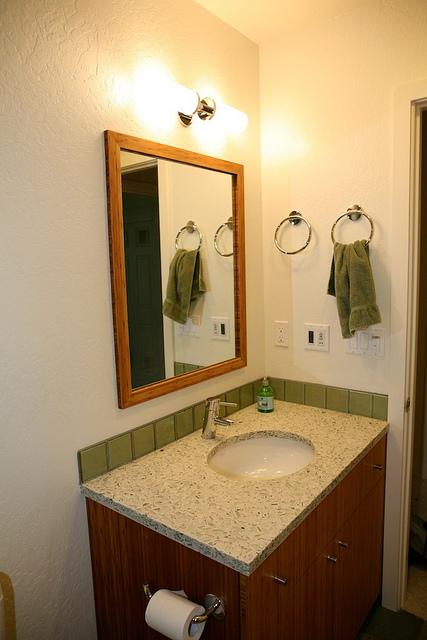How many handles are on the left side of the bathroom cabinet?
Write a very short answer. 1. Where are the lights?
Short answer required. Bathroom. How many light fixtures are in this picture?
Short answer required. 1. How many towels are hanging?
Quick response, please. 1. Are the lights on in this bathroom?
Quick response, please. Yes. What is in the mirror reflection?
Quick response, please. Towel. What type of wallpaper is here?
Short answer required. None. How many faucets?
Write a very short answer. 1. How many lamps are in the bathroom?
Answer briefly. 1. How many towel holders are there?
Write a very short answer. 2. Is there liquid soap on the sink?
Quick response, please. Yes. What plumbing device sits to the left of this sink?
Concise answer only. Toilet. What does the mirror reflect?
Keep it brief. Towel. What is cast?
Answer briefly. Light. What is above the sink?
Concise answer only. Mirror. 